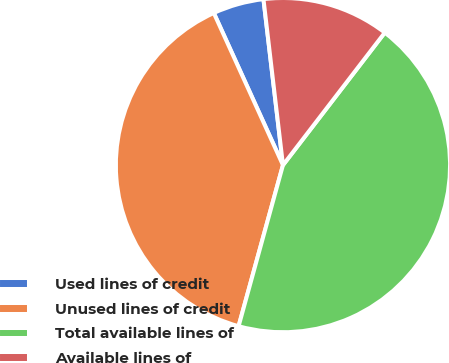Convert chart. <chart><loc_0><loc_0><loc_500><loc_500><pie_chart><fcel>Used lines of credit<fcel>Unused lines of credit<fcel>Total available lines of<fcel>Available lines of<nl><fcel>4.93%<fcel>38.93%<fcel>43.85%<fcel>12.29%<nl></chart> 